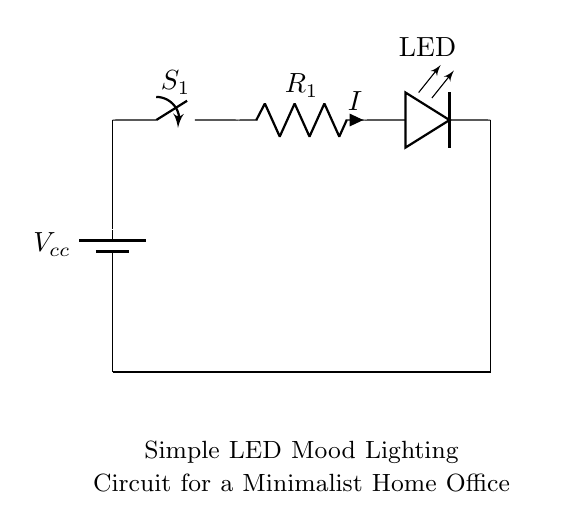What is the voltage source in this circuit? The circuit includes a voltage source labeled as Vcc, which provides the electrical potential for the circuit.
Answer: Vcc What component limits current in the circuit? The component that limits current flow in the circuit is labeled as R1, which is a resistor. Resistors reduce the flow of electric current by providing resistance.
Answer: R1 How many LEDs are in this circuit? The circuit contains one LED component labeled as LED, which indicates that there is only one light-emitting diode in the setup.
Answer: 1 What does the switch do in this circuit? The switch labeled S1 is used to open or close the circuit, allowing or interrupting the flow of current to the LED. If the switch is open, the circuit is incomplete and the LED will not light up; if closed, the current flows and the LED lights up.
Answer: Control current flow What is the purpose of the resistor in this circuit? The resistor R1 is used to limit the current flowing to the LED to prevent it from drawing too much current, which could potentially damage the LED. This ensures that the LED can operate safely at its intended brightness without exceeding current limits.
Answer: Limit current What is the direction of current flow in this circuit? The current flows from the positive terminal of the voltage source (Vcc), through the switch (S1), through the resistor (R1), through the LED, and then back to the negative terminal of the battery. This creates a complete loop for the current to flow, powering the LED.
Answer: From Vcc to LED What type of circuit is illustrated here? The circuit is a series circuit because all components (the battery, switch, resistor, and LED) are connected in a single path. In a series circuit, the same current flows through all components, and if one component fails or is disconnected, the entire circuit is interrupted.
Answer: Series circuit 